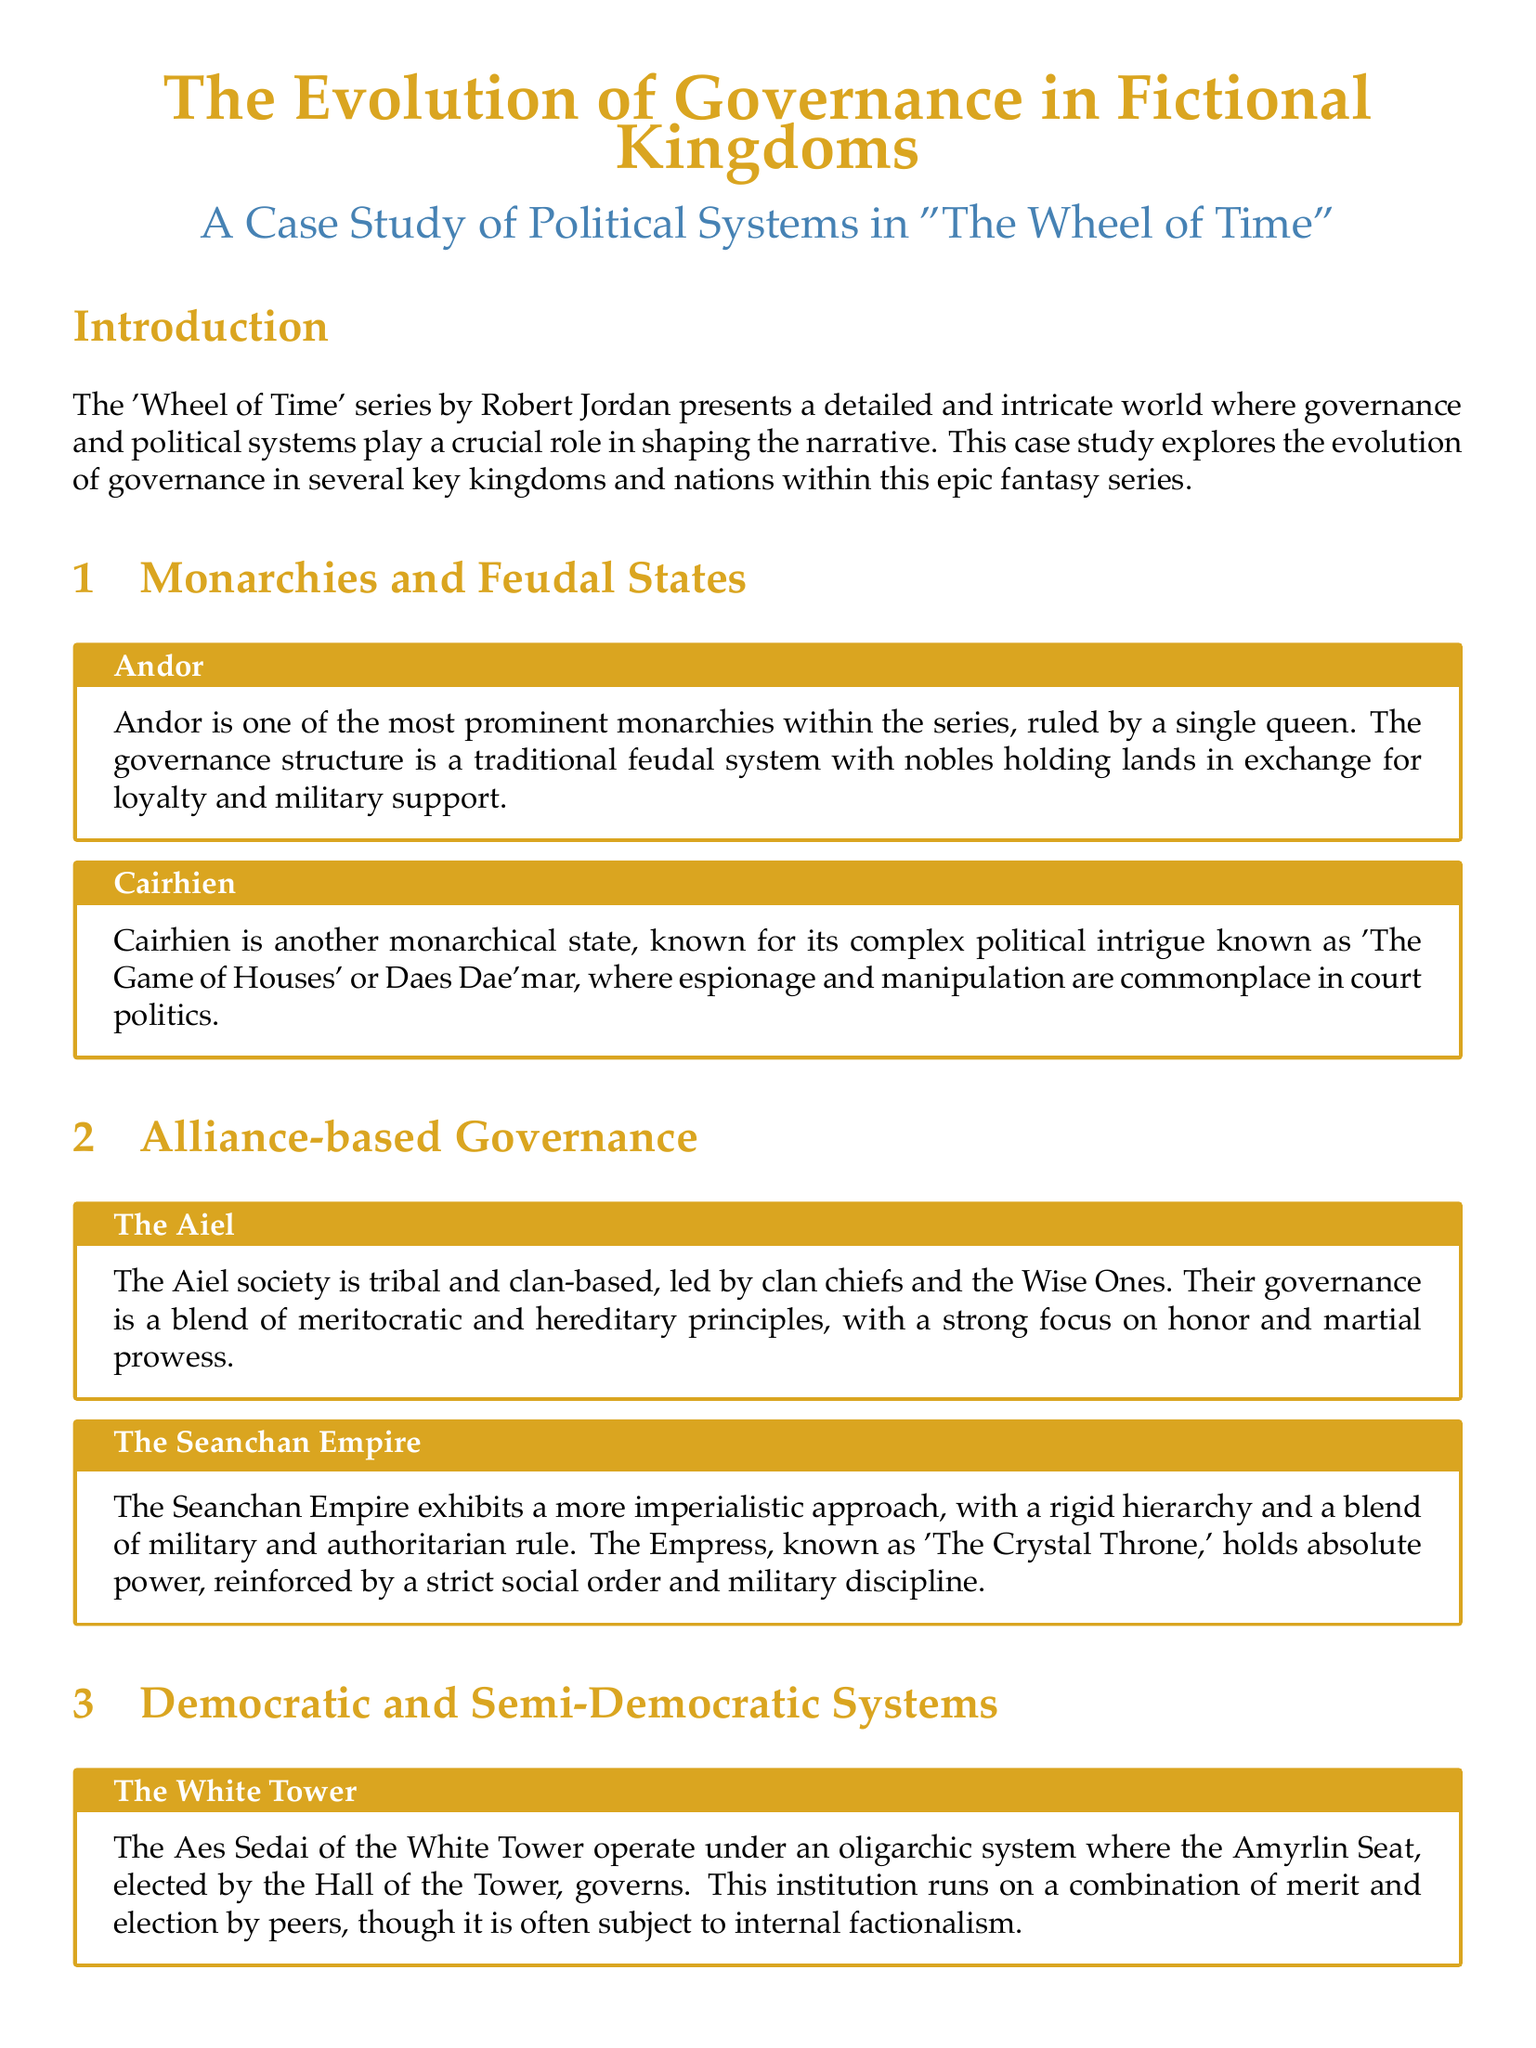What is the primary form of governance in Andor? Andor is described as a monarchy that operates under a traditional feudal system.
Answer: monarchy What political intrigue is Cairhien known for? Cairhien is known for its political intrigue described as 'The Game of Houses' or Daes Dae'mar.
Answer: The Game of Houses Who leads the Aiel society? The Aiel society is led by clan chiefs and the Wise Ones.
Answer: clan chiefs and the Wise Ones What kind of governance do the Two Rivers experience? The Two Rivers experiences a semi-democratic governance characterized by grassroots decision-making.
Answer: semi-democratic What is the title of the leader of the Aes Sedai in the White Tower? The leader of the Aes Sedai is referred to as the Amyrlin Seat.
Answer: Amyrlin Seat What impact does Rand al'Thor have on political systems? Rand al'Thor's arrival leads to shifts in power dynamics and centralization of power in some regions.
Answer: shifts in power dynamics Describe the governance structure of the Seanchan Empire. The Seanchan Empire has a rigid hierarchy with military and authoritarian rule.
Answer: military and authoritarian rule What type of political manipulation do the Forsaken engage in? The Forsaken manipulate existing political systems for their gain, often leading to corruption and coups.
Answer: manipulation for gain 